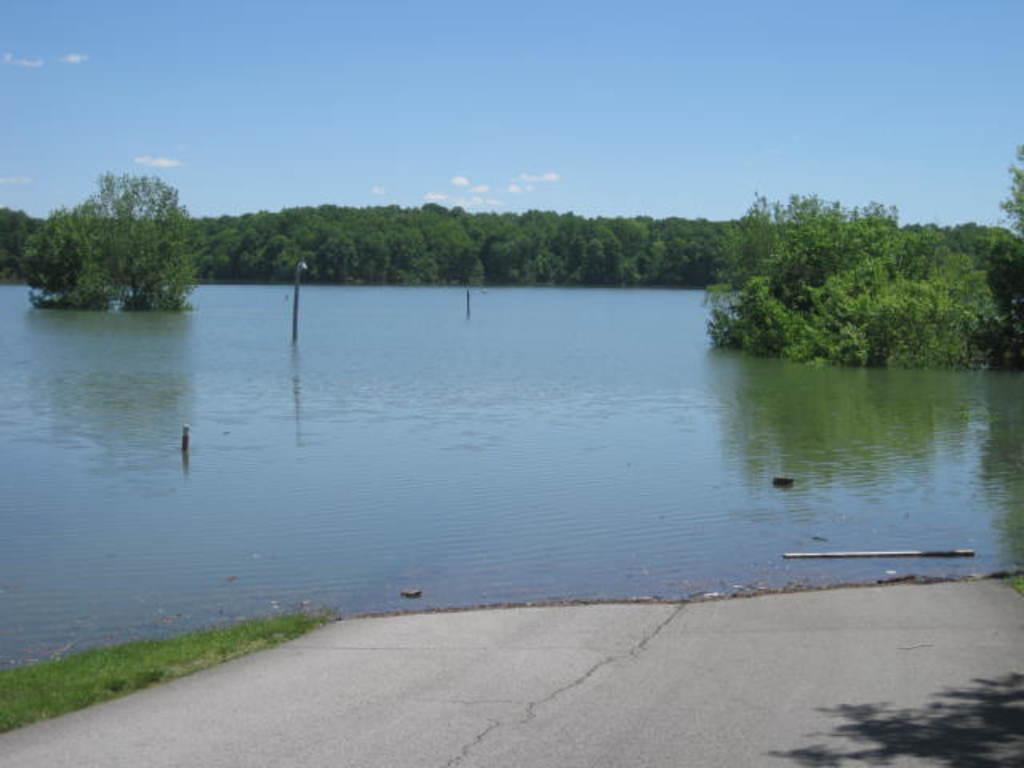What type of body of water is present in the image? There is a lake in the image. What can be seen inside the lake? There are poles inside the lake. What type of vegetation is visible in the image? There are plants and trees visible in the image. What type of ground cover is present in the image? There is grass in the image. What is the condition of the sky in the image? The sky is visible in the image and appears cloudy. What type of hospital is located near the lake in the image? There is no hospital present in the image; it only features a lake, poles, plants, trees, grass, and a cloudy sky. 